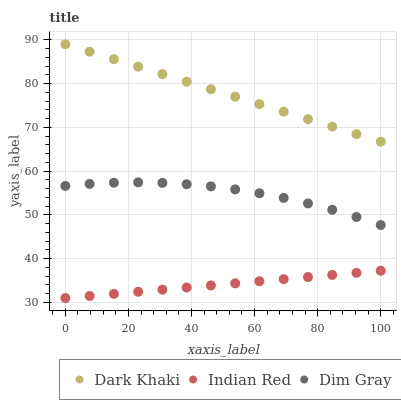Does Indian Red have the minimum area under the curve?
Answer yes or no. Yes. Does Dark Khaki have the maximum area under the curve?
Answer yes or no. Yes. Does Dim Gray have the minimum area under the curve?
Answer yes or no. No. Does Dim Gray have the maximum area under the curve?
Answer yes or no. No. Is Indian Red the smoothest?
Answer yes or no. Yes. Is Dim Gray the roughest?
Answer yes or no. Yes. Is Dim Gray the smoothest?
Answer yes or no. No. Is Indian Red the roughest?
Answer yes or no. No. Does Indian Red have the lowest value?
Answer yes or no. Yes. Does Dim Gray have the lowest value?
Answer yes or no. No. Does Dark Khaki have the highest value?
Answer yes or no. Yes. Does Dim Gray have the highest value?
Answer yes or no. No. Is Indian Red less than Dim Gray?
Answer yes or no. Yes. Is Dark Khaki greater than Dim Gray?
Answer yes or no. Yes. Does Indian Red intersect Dim Gray?
Answer yes or no. No. 